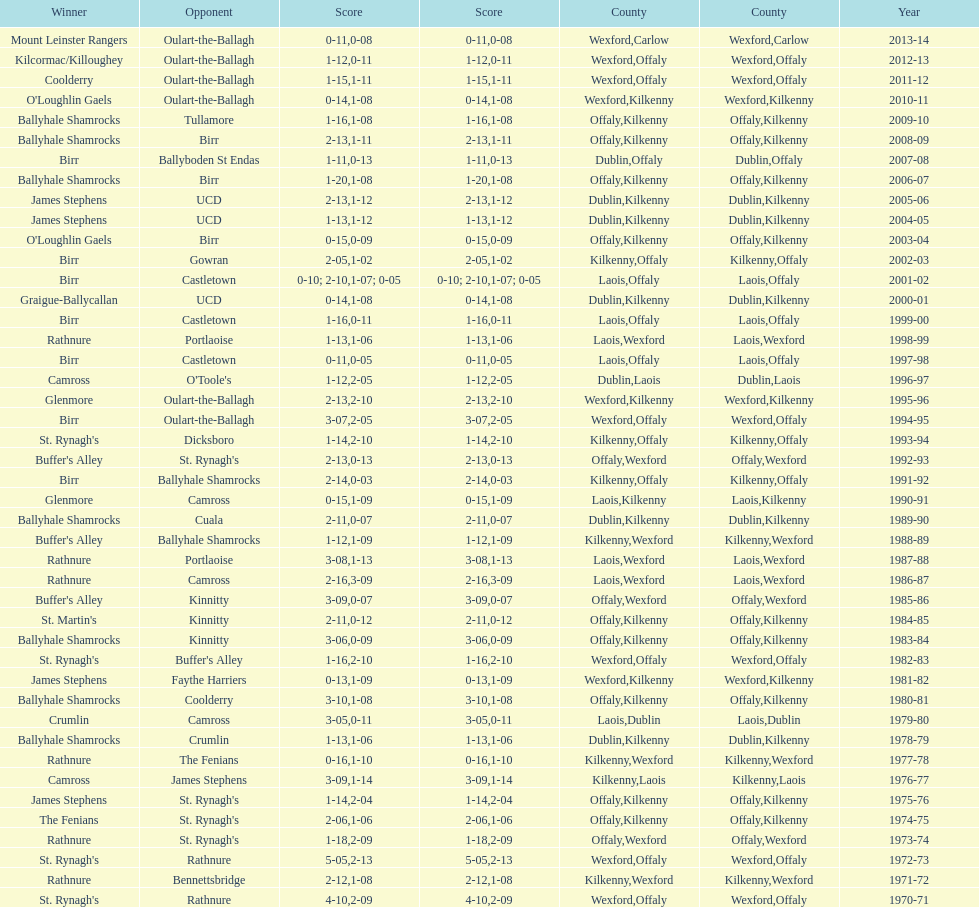Which team won the leinster senior club hurling championships previous to the last time birr won? Ballyhale Shamrocks. Write the full table. {'header': ['Winner', 'Opponent', 'Score', 'Score', 'County', 'County', 'Year'], 'rows': [['Mount Leinster Rangers', 'Oulart-the-Ballagh', '0-11', '0-08', 'Wexford', 'Carlow', '2013-14'], ['Kilcormac/Killoughey', 'Oulart-the-Ballagh', '1-12', '0-11', 'Wexford', 'Offaly', '2012-13'], ['Coolderry', 'Oulart-the-Ballagh', '1-15', '1-11', 'Wexford', 'Offaly', '2011-12'], ["O'Loughlin Gaels", 'Oulart-the-Ballagh', '0-14', '1-08', 'Wexford', 'Kilkenny', '2010-11'], ['Ballyhale Shamrocks', 'Tullamore', '1-16', '1-08', 'Offaly', 'Kilkenny', '2009-10'], ['Ballyhale Shamrocks', 'Birr', '2-13', '1-11', 'Offaly', 'Kilkenny', '2008-09'], ['Birr', 'Ballyboden St Endas', '1-11', '0-13', 'Dublin', 'Offaly', '2007-08'], ['Ballyhale Shamrocks', 'Birr', '1-20', '1-08', 'Offaly', 'Kilkenny', '2006-07'], ['James Stephens', 'UCD', '2-13', '1-12', 'Dublin', 'Kilkenny', '2005-06'], ['James Stephens', 'UCD', '1-13', '1-12', 'Dublin', 'Kilkenny', '2004-05'], ["O'Loughlin Gaels", 'Birr', '0-15', '0-09', 'Offaly', 'Kilkenny', '2003-04'], ['Birr', 'Gowran', '2-05', '1-02', 'Kilkenny', 'Offaly', '2002-03'], ['Birr', 'Castletown', '0-10; 2-10', '1-07; 0-05', 'Laois', 'Offaly', '2001-02'], ['Graigue-Ballycallan', 'UCD', '0-14', '1-08', 'Dublin', 'Kilkenny', '2000-01'], ['Birr', 'Castletown', '1-16', '0-11', 'Laois', 'Offaly', '1999-00'], ['Rathnure', 'Portlaoise', '1-13', '1-06', 'Laois', 'Wexford', '1998-99'], ['Birr', 'Castletown', '0-11', '0-05', 'Laois', 'Offaly', '1997-98'], ['Camross', "O'Toole's", '1-12', '2-05', 'Dublin', 'Laois', '1996-97'], ['Glenmore', 'Oulart-the-Ballagh', '2-13', '2-10', 'Wexford', 'Kilkenny', '1995-96'], ['Birr', 'Oulart-the-Ballagh', '3-07', '2-05', 'Wexford', 'Offaly', '1994-95'], ["St. Rynagh's", 'Dicksboro', '1-14', '2-10', 'Kilkenny', 'Offaly', '1993-94'], ["Buffer's Alley", "St. Rynagh's", '2-13', '0-13', 'Offaly', 'Wexford', '1992-93'], ['Birr', 'Ballyhale Shamrocks', '2-14', '0-03', 'Kilkenny', 'Offaly', '1991-92'], ['Glenmore', 'Camross', '0-15', '1-09', 'Laois', 'Kilkenny', '1990-91'], ['Ballyhale Shamrocks', 'Cuala', '2-11', '0-07', 'Dublin', 'Kilkenny', '1989-90'], ["Buffer's Alley", 'Ballyhale Shamrocks', '1-12', '1-09', 'Kilkenny', 'Wexford', '1988-89'], ['Rathnure', 'Portlaoise', '3-08', '1-13', 'Laois', 'Wexford', '1987-88'], ['Rathnure', 'Camross', '2-16', '3-09', 'Laois', 'Wexford', '1986-87'], ["Buffer's Alley", 'Kinnitty', '3-09', '0-07', 'Offaly', 'Wexford', '1985-86'], ["St. Martin's", 'Kinnitty', '2-11', '0-12', 'Offaly', 'Kilkenny', '1984-85'], ['Ballyhale Shamrocks', 'Kinnitty', '3-06', '0-09', 'Offaly', 'Kilkenny', '1983-84'], ["St. Rynagh's", "Buffer's Alley", '1-16', '2-10', 'Wexford', 'Offaly', '1982-83'], ['James Stephens', 'Faythe Harriers', '0-13', '1-09', 'Wexford', 'Kilkenny', '1981-82'], ['Ballyhale Shamrocks', 'Coolderry', '3-10', '1-08', 'Offaly', 'Kilkenny', '1980-81'], ['Crumlin', 'Camross', '3-05', '0-11', 'Laois', 'Dublin', '1979-80'], ['Ballyhale Shamrocks', 'Crumlin', '1-13', '1-06', 'Dublin', 'Kilkenny', '1978-79'], ['Rathnure', 'The Fenians', '0-16', '1-10', 'Kilkenny', 'Wexford', '1977-78'], ['Camross', 'James Stephens', '3-09', '1-14', 'Kilkenny', 'Laois', '1976-77'], ['James Stephens', "St. Rynagh's", '1-14', '2-04', 'Offaly', 'Kilkenny', '1975-76'], ['The Fenians', "St. Rynagh's", '2-06', '1-06', 'Offaly', 'Kilkenny', '1974-75'], ['Rathnure', "St. Rynagh's", '1-18', '2-09', 'Offaly', 'Wexford', '1973-74'], ["St. Rynagh's", 'Rathnure', '5-05', '2-13', 'Wexford', 'Offaly', '1972-73'], ['Rathnure', 'Bennettsbridge', '2-12', '1-08', 'Kilkenny', 'Wexford', '1971-72'], ["St. Rynagh's", 'Rathnure', '4-10', '2-09', 'Wexford', 'Offaly', '1970-71']]} 